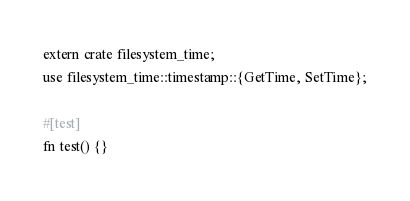<code> <loc_0><loc_0><loc_500><loc_500><_Rust_>extern crate filesystem_time;
use filesystem_time::timestamp::{GetTime, SetTime};

#[test]
fn test() {}
</code> 